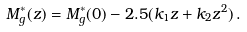<formula> <loc_0><loc_0><loc_500><loc_500>M _ { g } ^ { * } ( z ) = M _ { g } ^ { * } ( 0 ) - 2 . 5 ( k _ { 1 } z + k _ { 2 } z ^ { 2 } ) \, .</formula> 